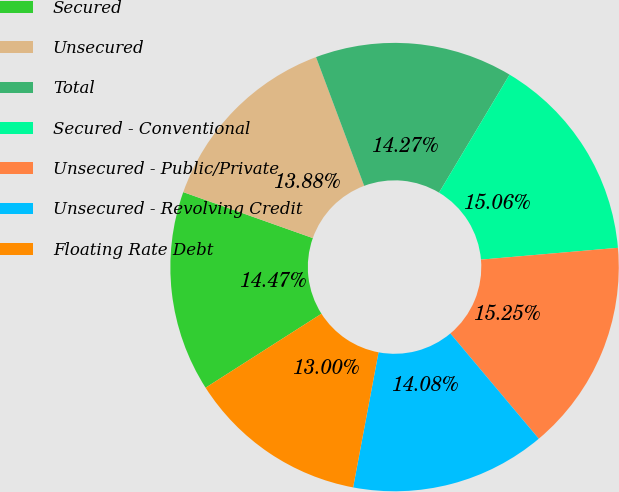Convert chart. <chart><loc_0><loc_0><loc_500><loc_500><pie_chart><fcel>Secured<fcel>Unsecured<fcel>Total<fcel>Secured - Conventional<fcel>Unsecured - Public/Private<fcel>Unsecured - Revolving Credit<fcel>Floating Rate Debt<nl><fcel>14.47%<fcel>13.88%<fcel>14.27%<fcel>15.06%<fcel>15.25%<fcel>14.08%<fcel>13.0%<nl></chart> 